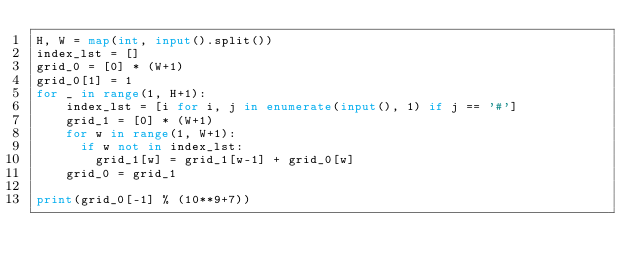<code> <loc_0><loc_0><loc_500><loc_500><_Python_>H, W = map(int, input().split())
index_lst = []
grid_0 = [0] * (W+1)
grid_0[1] = 1
for _ in range(1, H+1):
    index_lst = [i for i, j in enumerate(input(), 1) if j == '#']
    grid_1 = [0] * (W+1)
    for w in range(1, W+1):
      if w not in index_lst:
      	grid_1[w] = grid_1[w-1] + grid_0[w]
    grid_0 = grid_1

print(grid_0[-1] % (10**9+7))</code> 